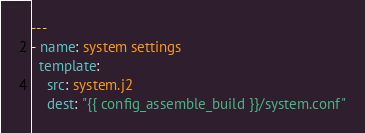Convert code to text. <code><loc_0><loc_0><loc_500><loc_500><_YAML_>---
- name: system settings
  template:
    src: system.j2
    dest: "{{ config_assemble_build }}/system.conf"
</code> 